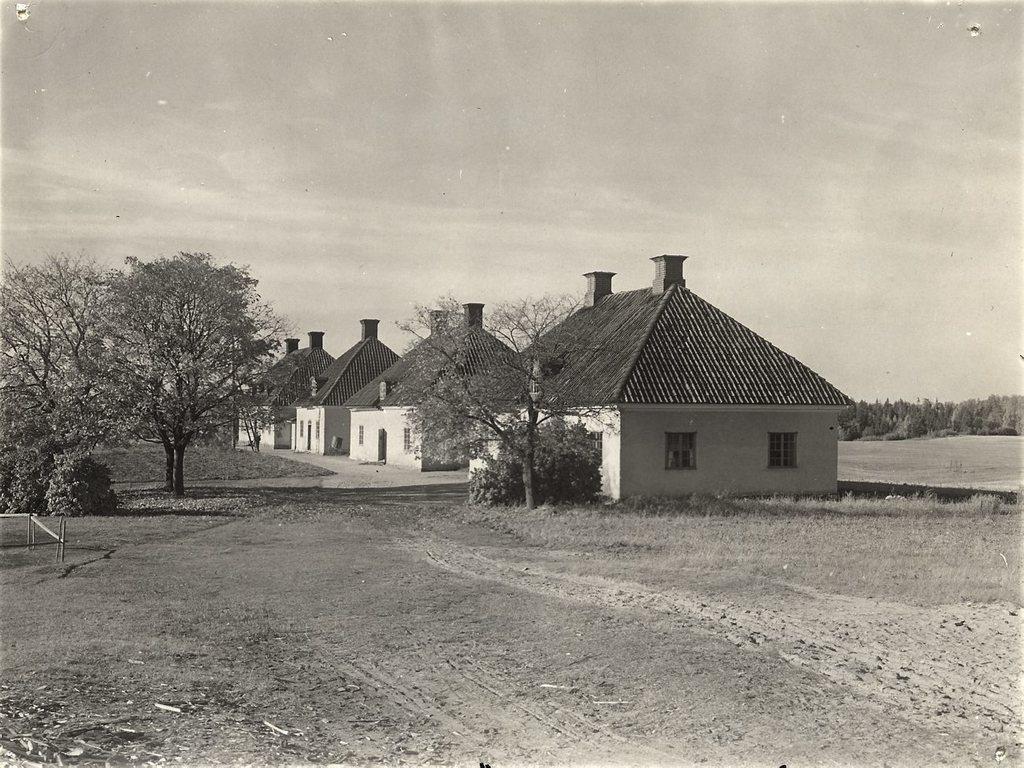How would you summarize this image in a sentence or two? It is a black and white picture. In this picture there are trees, plants, houses and sky.   